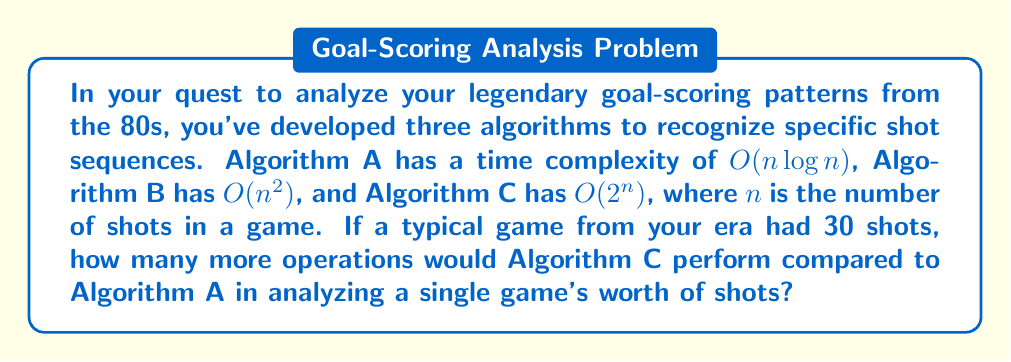Provide a solution to this math problem. To solve this problem, we need to compare the number of operations performed by Algorithm C and Algorithm A for $n = 30$ shots. Let's break it down step-by-step:

1. For Algorithm A with $O(n \log n)$ complexity:
   - Number of operations $\approx k_1 \cdot n \log n$
   - $\approx k_1 \cdot 30 \log 30$
   - $\approx k_1 \cdot 30 \cdot 4.91$ (since $\log 30 \approx 4.91$)
   - $\approx 147.3k_1$

2. For Algorithm C with $O(2^n)$ complexity:
   - Number of operations $\approx k_2 \cdot 2^n$
   - $\approx k_2 \cdot 2^{30}$
   - $\approx k_2 \cdot 1,073,741,824$

3. Difference in operations:
   $k_2 \cdot 1,073,741,824 - k_1 \cdot 147.3$

4. Assuming $k_1 \approx k_2$ (as they are both constants), we can simplify:
   $\approx 1,073,741,824 - 147.3$
   $\approx 1,073,741,676.7$

Therefore, Algorithm C would perform approximately 1,073,741,677 more operations than Algorithm A for analyzing a single game with 30 shots.
Answer: Algorithm C would perform approximately 1,073,741,677 more operations than Algorithm A. 